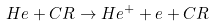Convert formula to latex. <formula><loc_0><loc_0><loc_500><loc_500>H e + C R \to H e ^ { + } + e + C R</formula> 